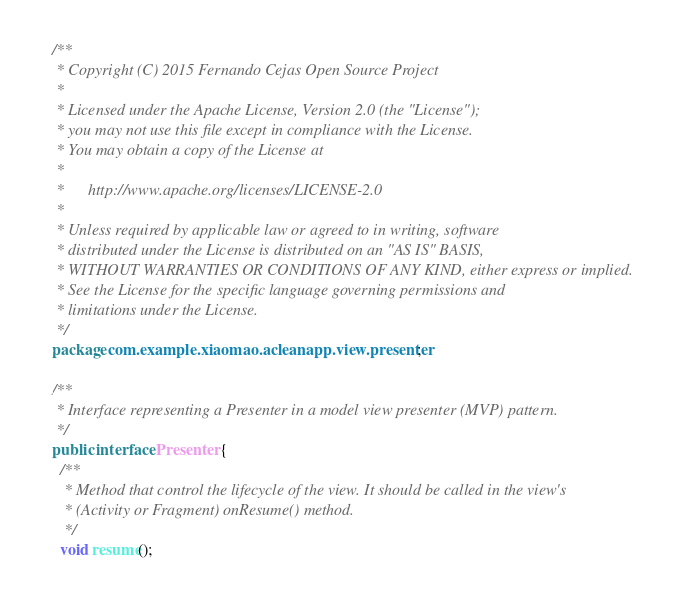<code> <loc_0><loc_0><loc_500><loc_500><_Java_>/**
 * Copyright (C) 2015 Fernando Cejas Open Source Project
 *
 * Licensed under the Apache License, Version 2.0 (the "License");
 * you may not use this file except in compliance with the License.
 * You may obtain a copy of the License at
 *
 *      http://www.apache.org/licenses/LICENSE-2.0
 *
 * Unless required by applicable law or agreed to in writing, software
 * distributed under the License is distributed on an "AS IS" BASIS,
 * WITHOUT WARRANTIES OR CONDITIONS OF ANY KIND, either express or implied.
 * See the License for the specific language governing permissions and
 * limitations under the License.
 */
package com.example.xiaomao.acleanapp.view.presenter;

/**
 * Interface representing a Presenter in a model view presenter (MVP) pattern.
 */
public interface Presenter {
  /**
   * Method that control the lifecycle of the view. It should be called in the view's
   * (Activity or Fragment) onResume() method.
   */
  void resume();
</code> 